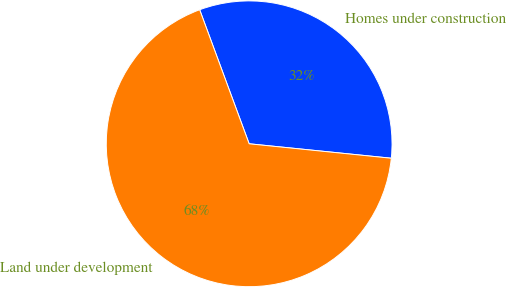<chart> <loc_0><loc_0><loc_500><loc_500><pie_chart><fcel>Homes under construction<fcel>Land under development<nl><fcel>32.24%<fcel>67.76%<nl></chart> 